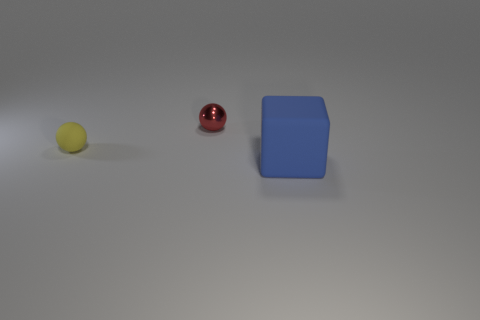Add 2 large blue things. How many objects exist? 5 Subtract all balls. How many objects are left? 1 Subtract all blue objects. Subtract all red shiny balls. How many objects are left? 1 Add 1 small metal objects. How many small metal objects are left? 2 Add 3 brown things. How many brown things exist? 3 Subtract 0 green cylinders. How many objects are left? 3 